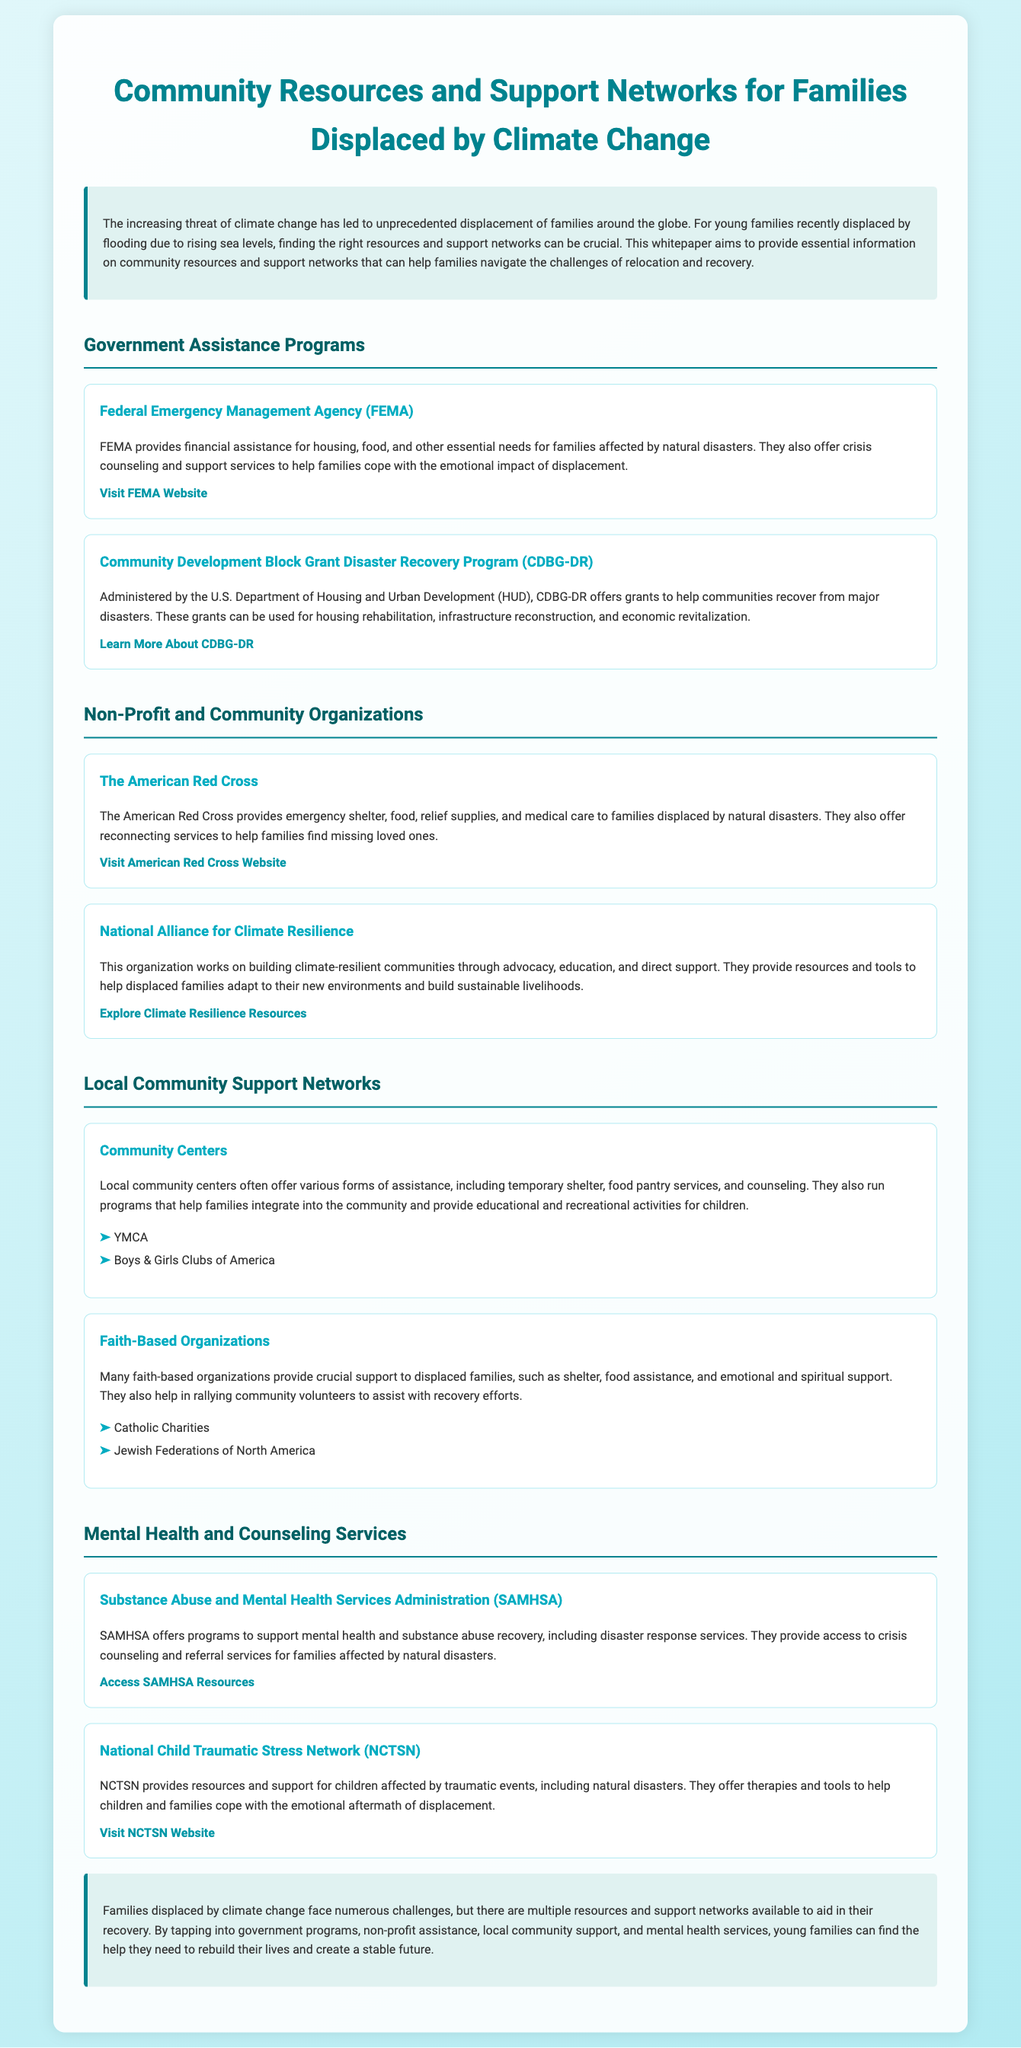what organization provides financial assistance for housing after natural disasters? The organization that provides financial assistance for housing after natural disasters is FEMA.
Answer: FEMA what does CDBG-DR stand for? CDBG-DR stands for Community Development Block Grant Disaster Recovery Program.
Answer: CDBG-DR which organization offers emergency shelter and food to families displaced by disasters? The American Red Cross offers emergency shelter and food to families displaced by disasters.
Answer: The American Red Cross name one local community support option mentioned in the document. One local community support option mentioned is the YMCA.
Answer: YMCA what type of services does SAMHSA provide? SAMHSA provides mental health and substance abuse recovery services.
Answer: mental health and substance abuse recovery which organization works on building climate-resilient communities? The organization that works on building climate-resilient communities is the National Alliance for Climate Resilience.
Answer: National Alliance for Climate Resilience how many resources are listed under Mental Health and Counseling Services? Two resources are listed under Mental Health and Counseling Services.
Answer: Two what is the primary focus of the National Child Traumatic Stress Network? The primary focus of the National Child Traumatic Stress Network is to provide support for children affected by traumatic events.
Answer: support for children affected by traumatic events what type of support do faith-based organizations provide? Faith-based organizations provide shelter, food assistance, and emotional support.
Answer: shelter, food assistance, and emotional support 